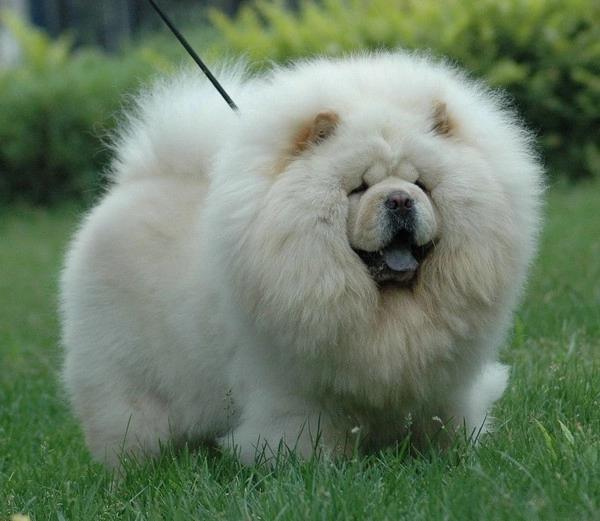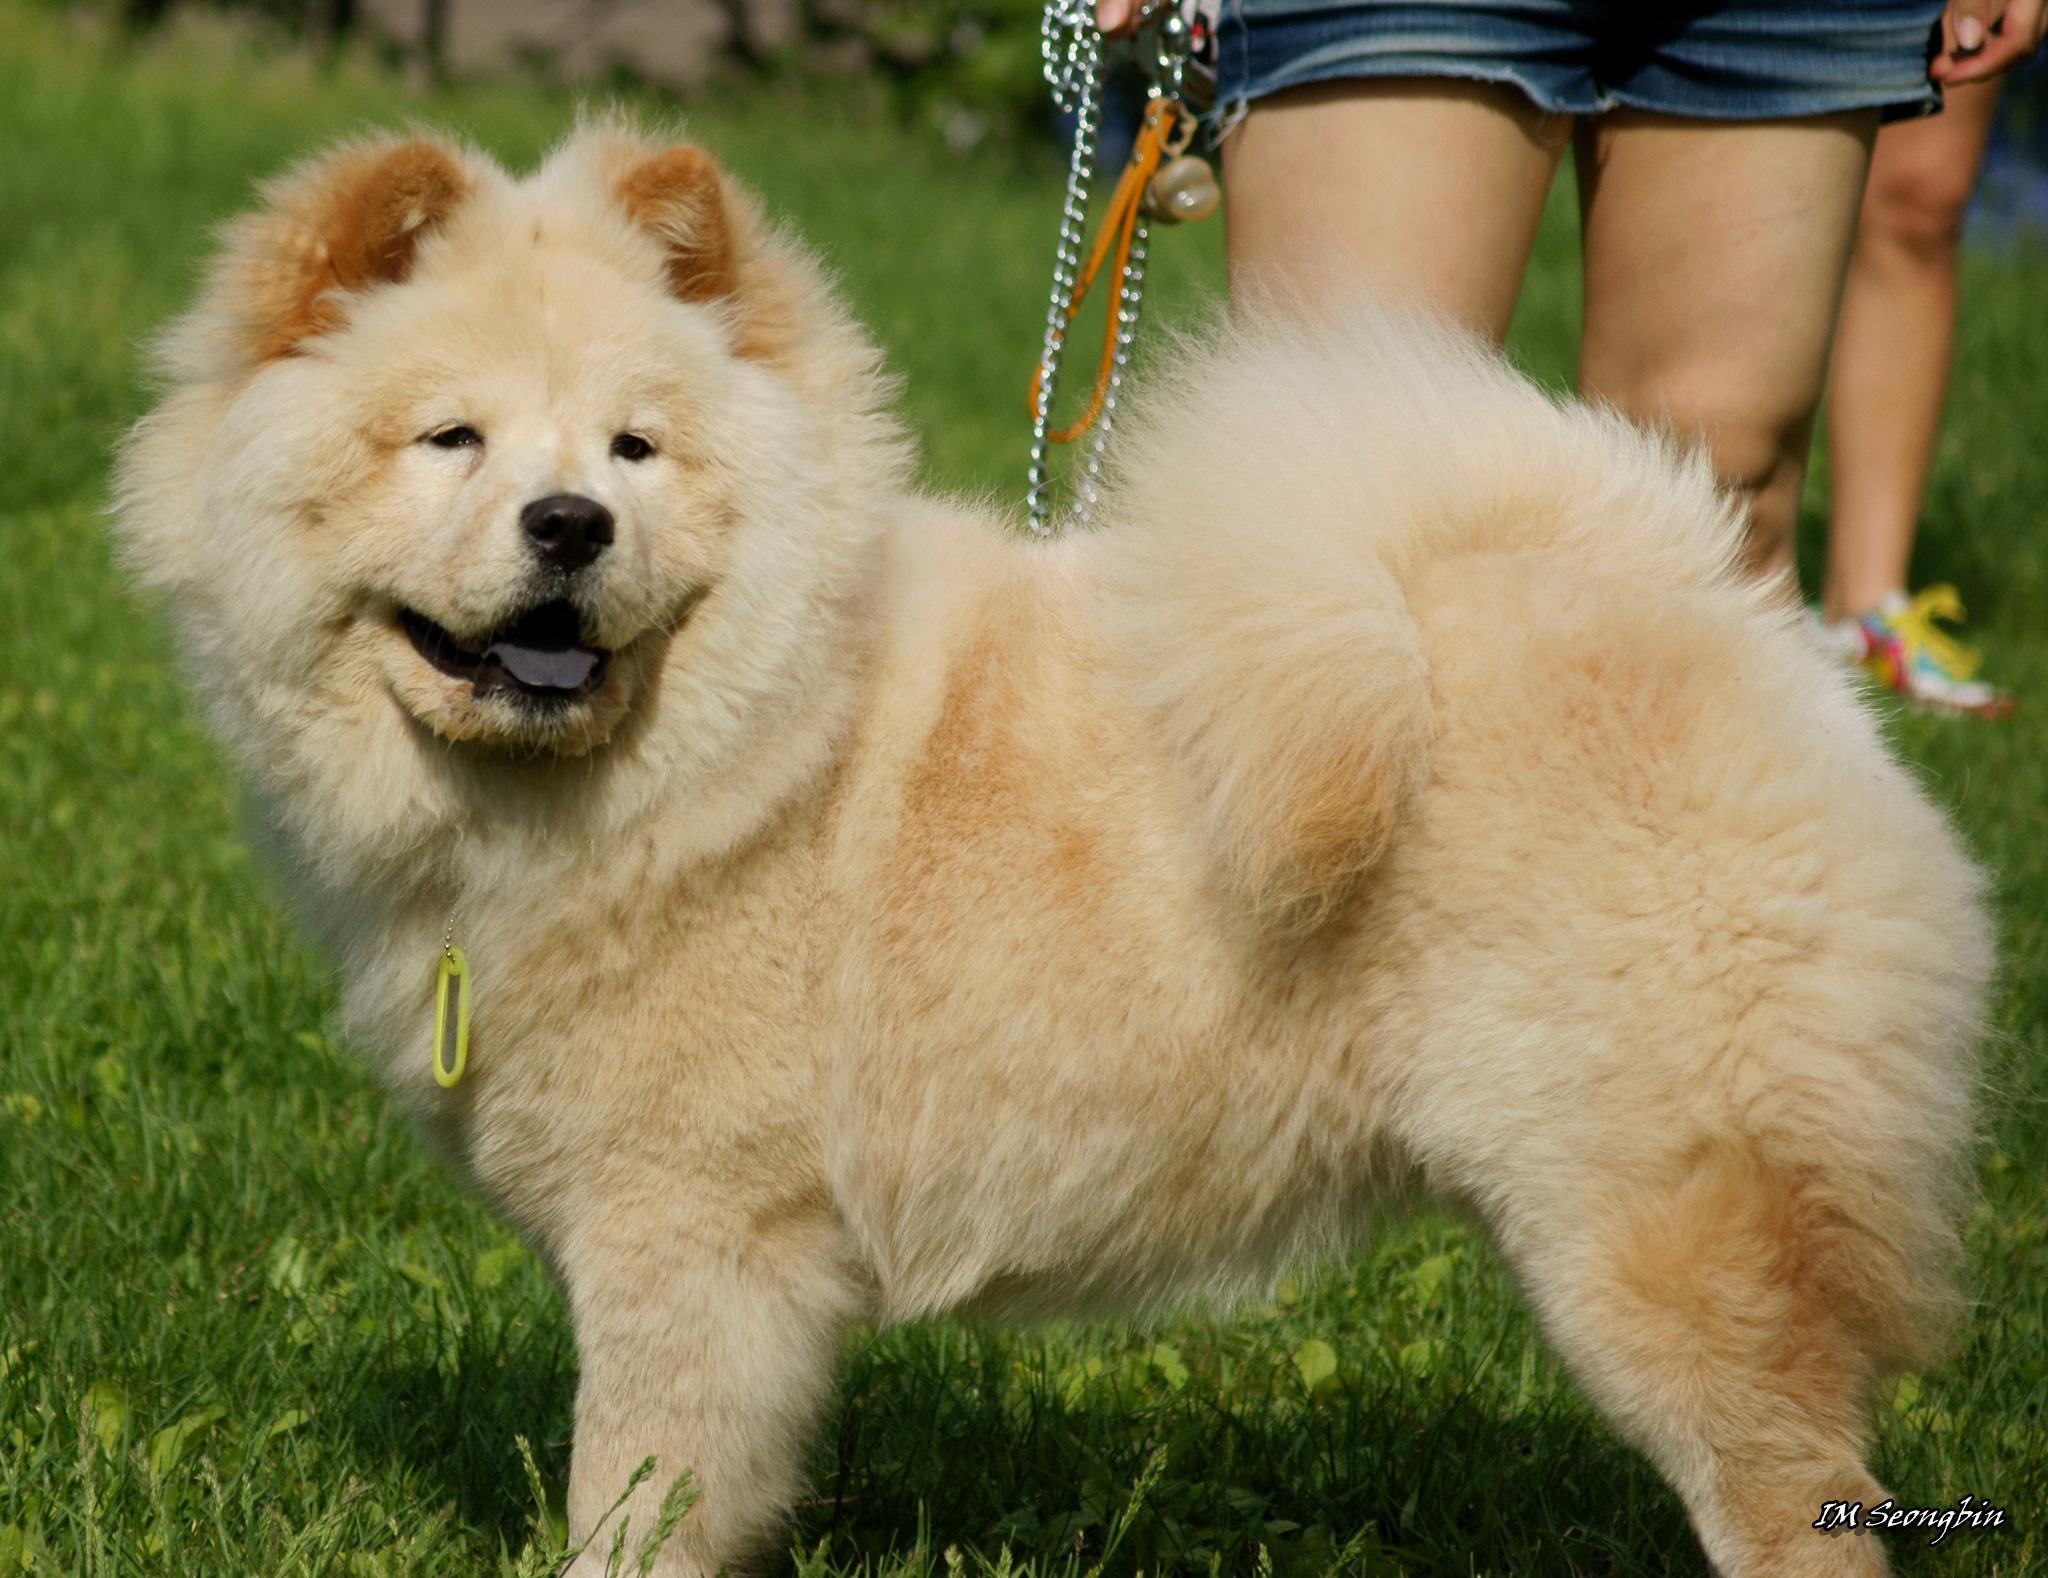The first image is the image on the left, the second image is the image on the right. Examine the images to the left and right. Is the description "Two dogs are standing." accurate? Answer yes or no. Yes. The first image is the image on the left, the second image is the image on the right. For the images shown, is this caption "Each image shows a chow dog standing on grass, and one image shows a dog standing with its body turned leftward." true? Answer yes or no. Yes. 